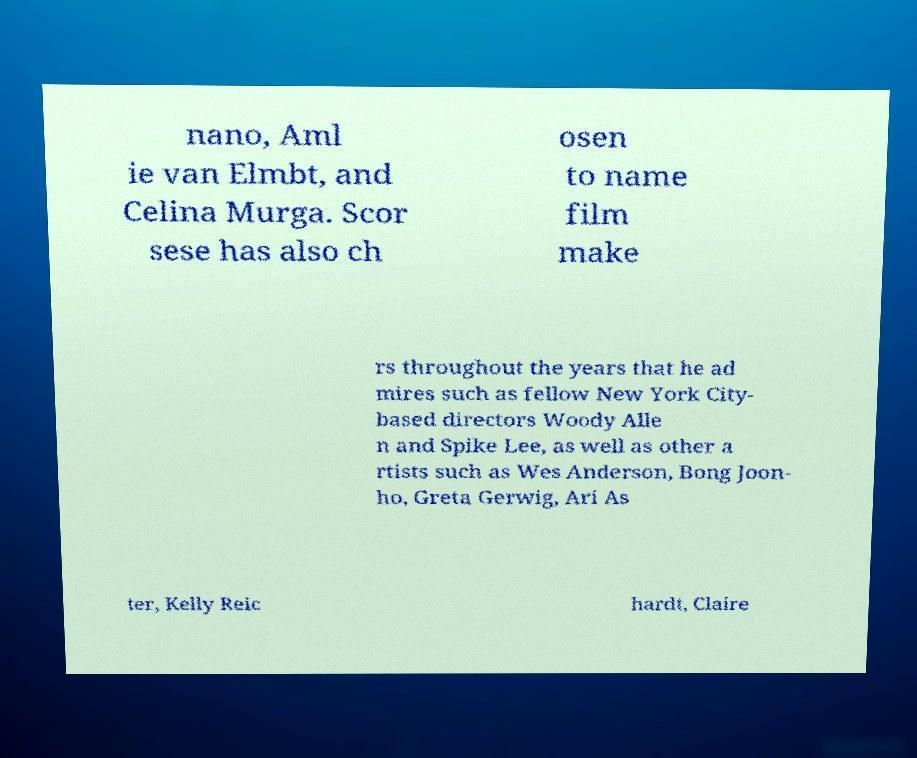Could you assist in decoding the text presented in this image and type it out clearly? nano, Aml ie van Elmbt, and Celina Murga. Scor sese has also ch osen to name film make rs throughout the years that he ad mires such as fellow New York City- based directors Woody Alle n and Spike Lee, as well as other a rtists such as Wes Anderson, Bong Joon- ho, Greta Gerwig, Ari As ter, Kelly Reic hardt, Claire 